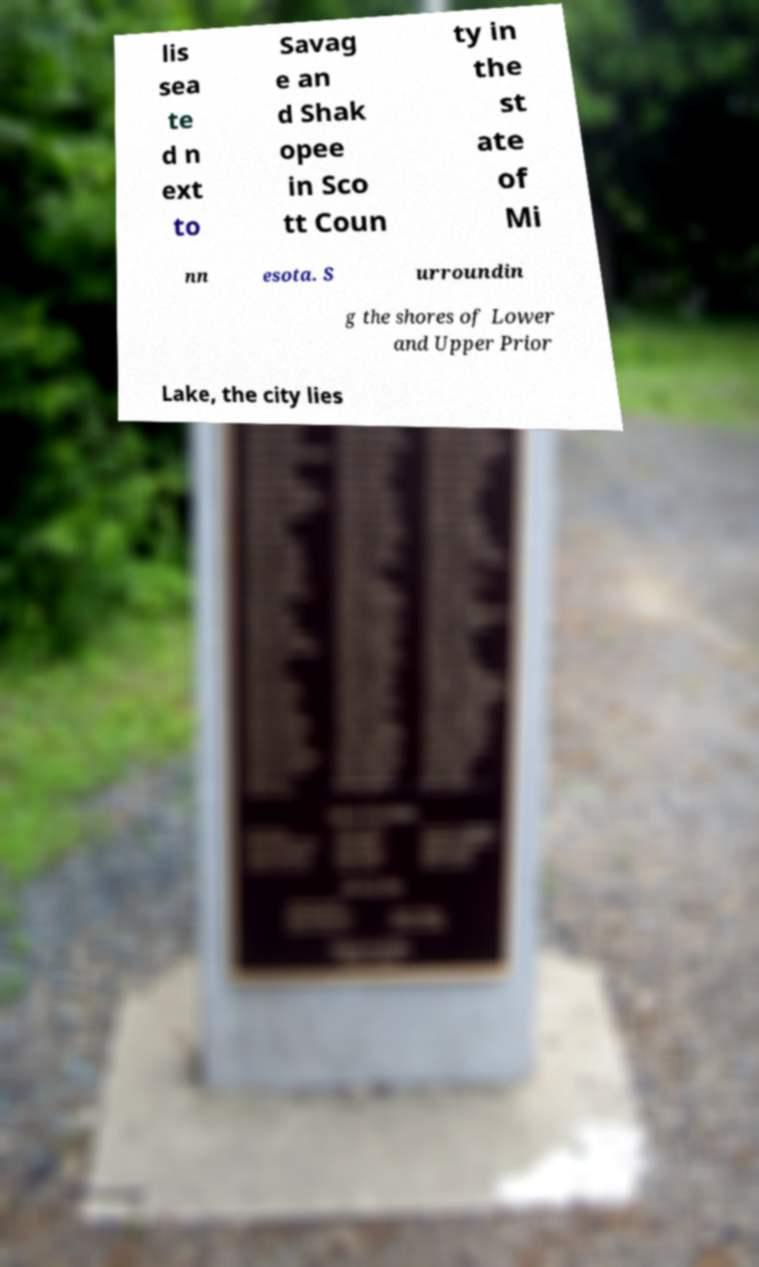I need the written content from this picture converted into text. Can you do that? lis sea te d n ext to Savag e an d Shak opee in Sco tt Coun ty in the st ate of Mi nn esota. S urroundin g the shores of Lower and Upper Prior Lake, the city lies 